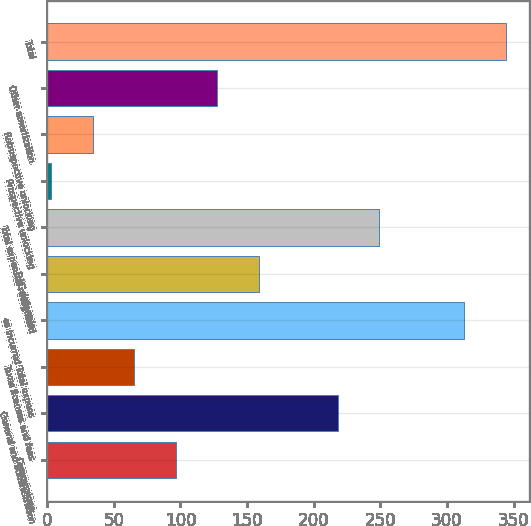<chart> <loc_0><loc_0><loc_500><loc_500><bar_chart><fcel>Commissions<fcel>General and administration<fcel>Taxes licenses and fees<fcel>es incurred Total expens<fcel>DAC deferrals<fcel>Total expenses recognized<fcel>Prospective unlocking<fcel>Retrospective unlocking<fcel>Other amortization<fcel>Total<nl><fcel>96.6<fcel>218<fcel>65.4<fcel>313<fcel>159<fcel>249.2<fcel>3<fcel>34.2<fcel>127.8<fcel>344.2<nl></chart> 